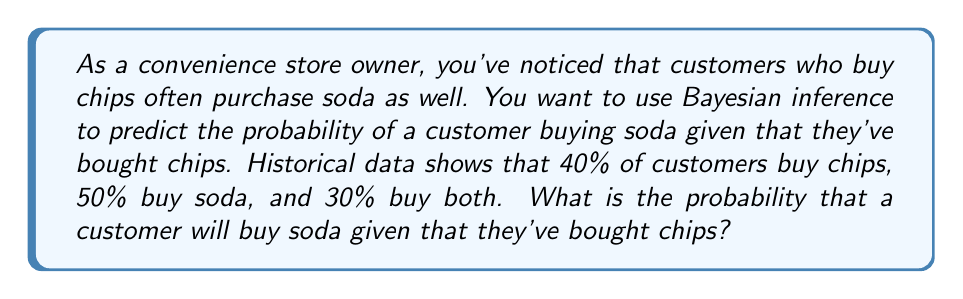What is the answer to this math problem? Let's approach this step-by-step using Bayes' theorem:

1) Define our events:
   A: Customer buys chips
   B: Customer buys soda

2) Given probabilities:
   $P(A) = 0.40$ (probability of buying chips)
   $P(B) = 0.50$ (probability of buying soda)
   $P(A \cap B) = 0.30$ (probability of buying both chips and soda)

3) We want to find $P(B|A)$, the probability of buying soda given that chips were bought.

4) Bayes' theorem states:

   $$P(B|A) = \frac{P(A|B) \cdot P(B)}{P(A)}$$

5) We know $P(B)$ and $P(A)$, but we need to calculate $P(A|B)$:

   $$P(A|B) = \frac{P(A \cap B)}{P(B)} = \frac{0.30}{0.50} = 0.60$$

6) Now we can apply Bayes' theorem:

   $$P(B|A) = \frac{0.60 \cdot 0.50}{0.40} = \frac{0.30}{0.40} = 0.75$$

7) Therefore, the probability that a customer will buy soda given that they've bought chips is 0.75 or 75%.
Answer: 0.75 